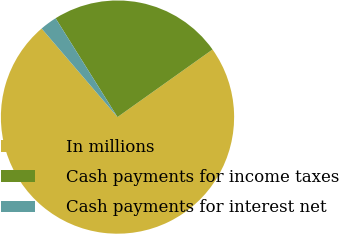Convert chart to OTSL. <chart><loc_0><loc_0><loc_500><loc_500><pie_chart><fcel>In millions<fcel>Cash payments for income taxes<fcel>Cash payments for interest net<nl><fcel>73.56%<fcel>24.07%<fcel>2.37%<nl></chart> 